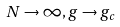<formula> <loc_0><loc_0><loc_500><loc_500>N \to \infty , g \to g _ { c }</formula> 